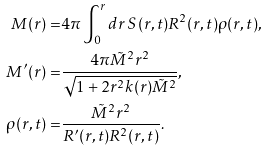Convert formula to latex. <formula><loc_0><loc_0><loc_500><loc_500>M ( r ) = & 4 \pi \int _ { 0 } ^ { r } d r \, S ( r , t ) R ^ { 2 } ( r , t ) \rho ( r , t ) , \\ M ^ { \prime } ( r ) = & \frac { 4 \pi \tilde { M } ^ { 2 } r ^ { 2 } } { \sqrt { 1 + 2 r ^ { 2 } k ( r ) \tilde { M } ^ { 2 } } } , \\ \rho ( r , t ) = & \frac { \tilde { M } ^ { 2 } r ^ { 2 } } { R ^ { \prime } ( r , t ) R ^ { 2 } ( r , t ) } .</formula> 